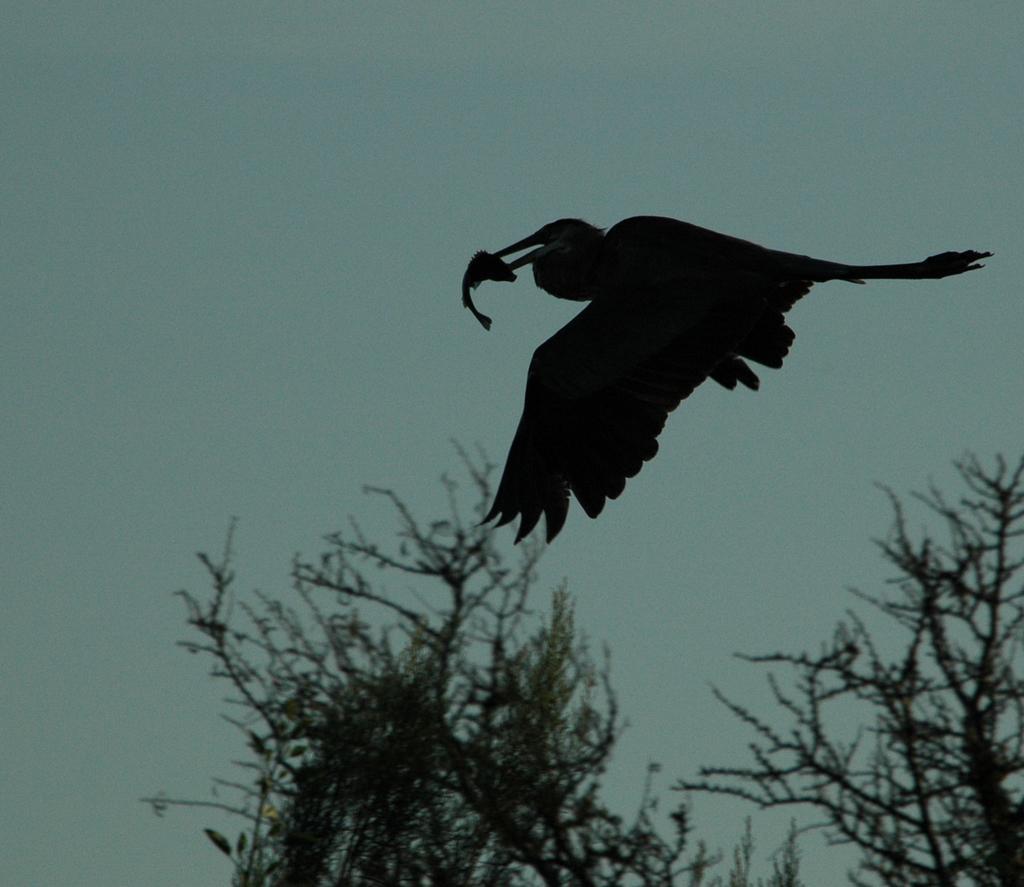Describe this image in one or two sentences. In this picture, we see a bird is flying in the sky. This bird is in black color. It has a long beak and it is holding something in its beak. At the bottom of the picture, we see trees. In the background, we see the sky. 